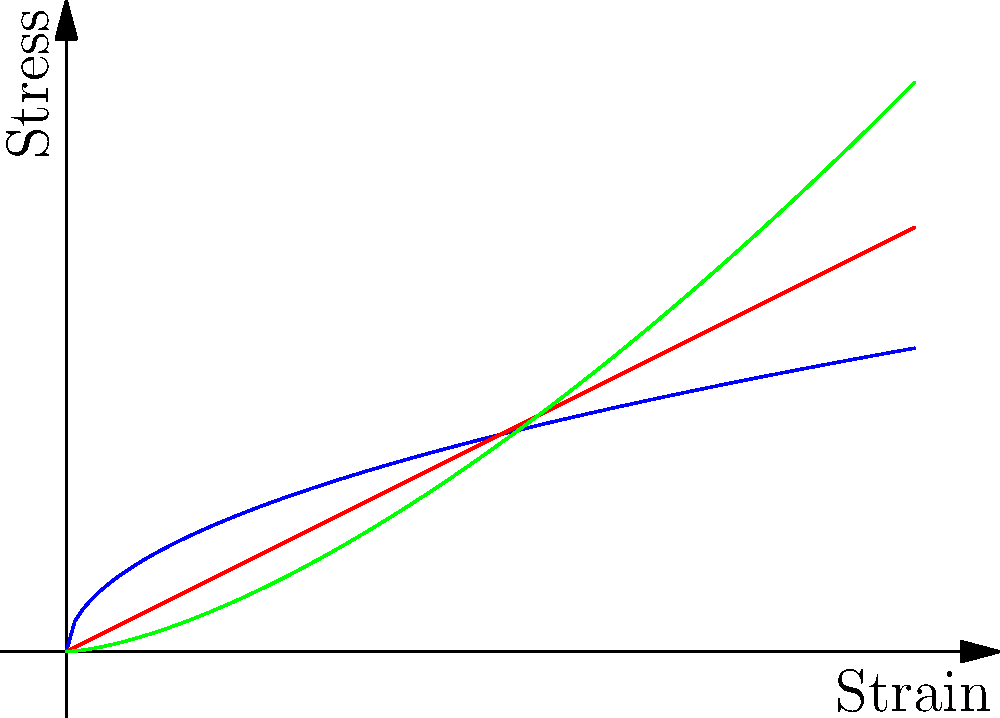In the stress-strain curves shown for bone, tendon, and ligament, which tissue demonstrates the highest initial stiffness and why is this characteristic important for its function in the body? To answer this question, we need to analyze the stress-strain curves and understand the concept of initial stiffness:

1. Initial stiffness is represented by the slope of the curve at the beginning (near the origin).
2. A steeper initial slope indicates higher initial stiffness.
3. Examining the curves:
   - Bone (blue): Starts with a steep curve
   - Tendon (red): Starts with a straight line, less steep than bone
   - Ligament (green): Starts with a shallow curve

4. The bone curve has the steepest initial slope, indicating the highest initial stiffness.

5. Importance for function:
   - High initial stiffness in bone allows it to resist deformation under small loads.
   - This property is crucial for bone's role in:
     a) Maintaining skeletal structure
     b) Protecting internal organs
     c) Enabling efficient force transmission during movement

6. The high initial stiffness of bone contributes to its ability to withstand the various forces it encounters during daily activities without significant deformation, ensuring structural integrity of the skeletal system.
Answer: Bone; highest initial stiffness enables resistance to deformation, maintaining skeletal structure and protecting organs. 